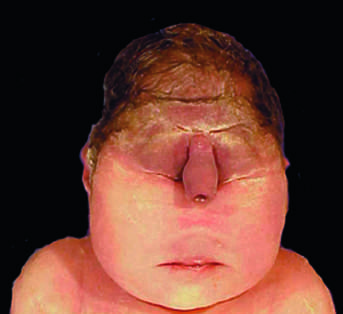how is stillbirth associated?
Answer the question using a single word or phrase. With a lethal malformation 